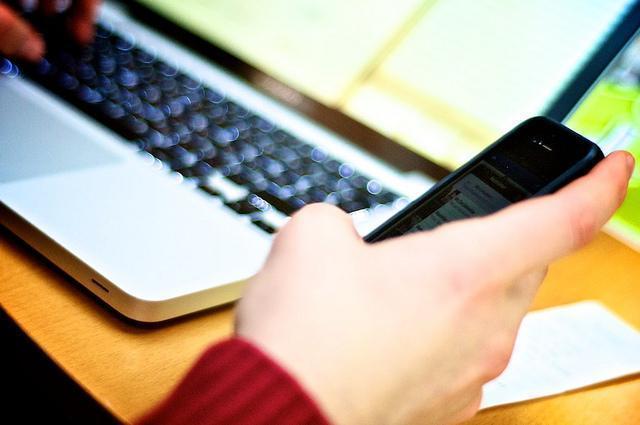How many keyboards are in the photo?
Give a very brief answer. 1. 